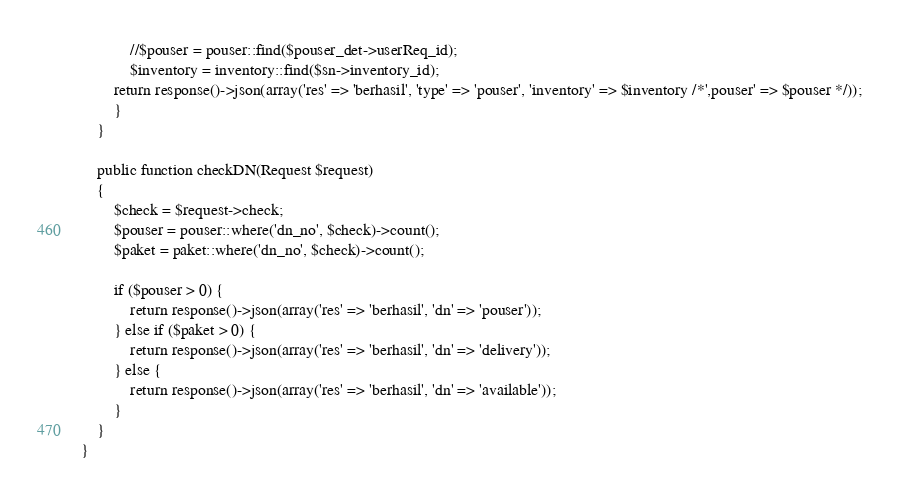Convert code to text. <code><loc_0><loc_0><loc_500><loc_500><_PHP_>            //$pouser = pouser::find($pouser_det->userReq_id);
            $inventory = inventory::find($sn->inventory_id);
        return response()->json(array('res' => 'berhasil', 'type' => 'pouser', 'inventory' => $inventory /*',pouser' => $pouser */));
        }
    }

    public function checkDN(Request $request)
    {
        $check = $request->check;
        $pouser = pouser::where('dn_no', $check)->count();
        $paket = paket::where('dn_no', $check)->count();

        if ($pouser > 0) {
            return response()->json(array('res' => 'berhasil', 'dn' => 'pouser'));
        } else if ($paket > 0) {
            return response()->json(array('res' => 'berhasil', 'dn' => 'delivery'));
        } else {
            return response()->json(array('res' => 'berhasil', 'dn' => 'available'));
        }
    }
}
</code> 